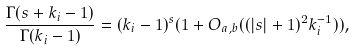Convert formula to latex. <formula><loc_0><loc_0><loc_500><loc_500>\frac { \Gamma ( s + k _ { i } - 1 ) } { \Gamma ( k _ { i } - 1 ) } = ( k _ { i } - 1 ) ^ { s } ( 1 + O _ { a , b } ( ( | s | + 1 ) ^ { 2 } k _ { i } ^ { - 1 } ) ) ,</formula> 